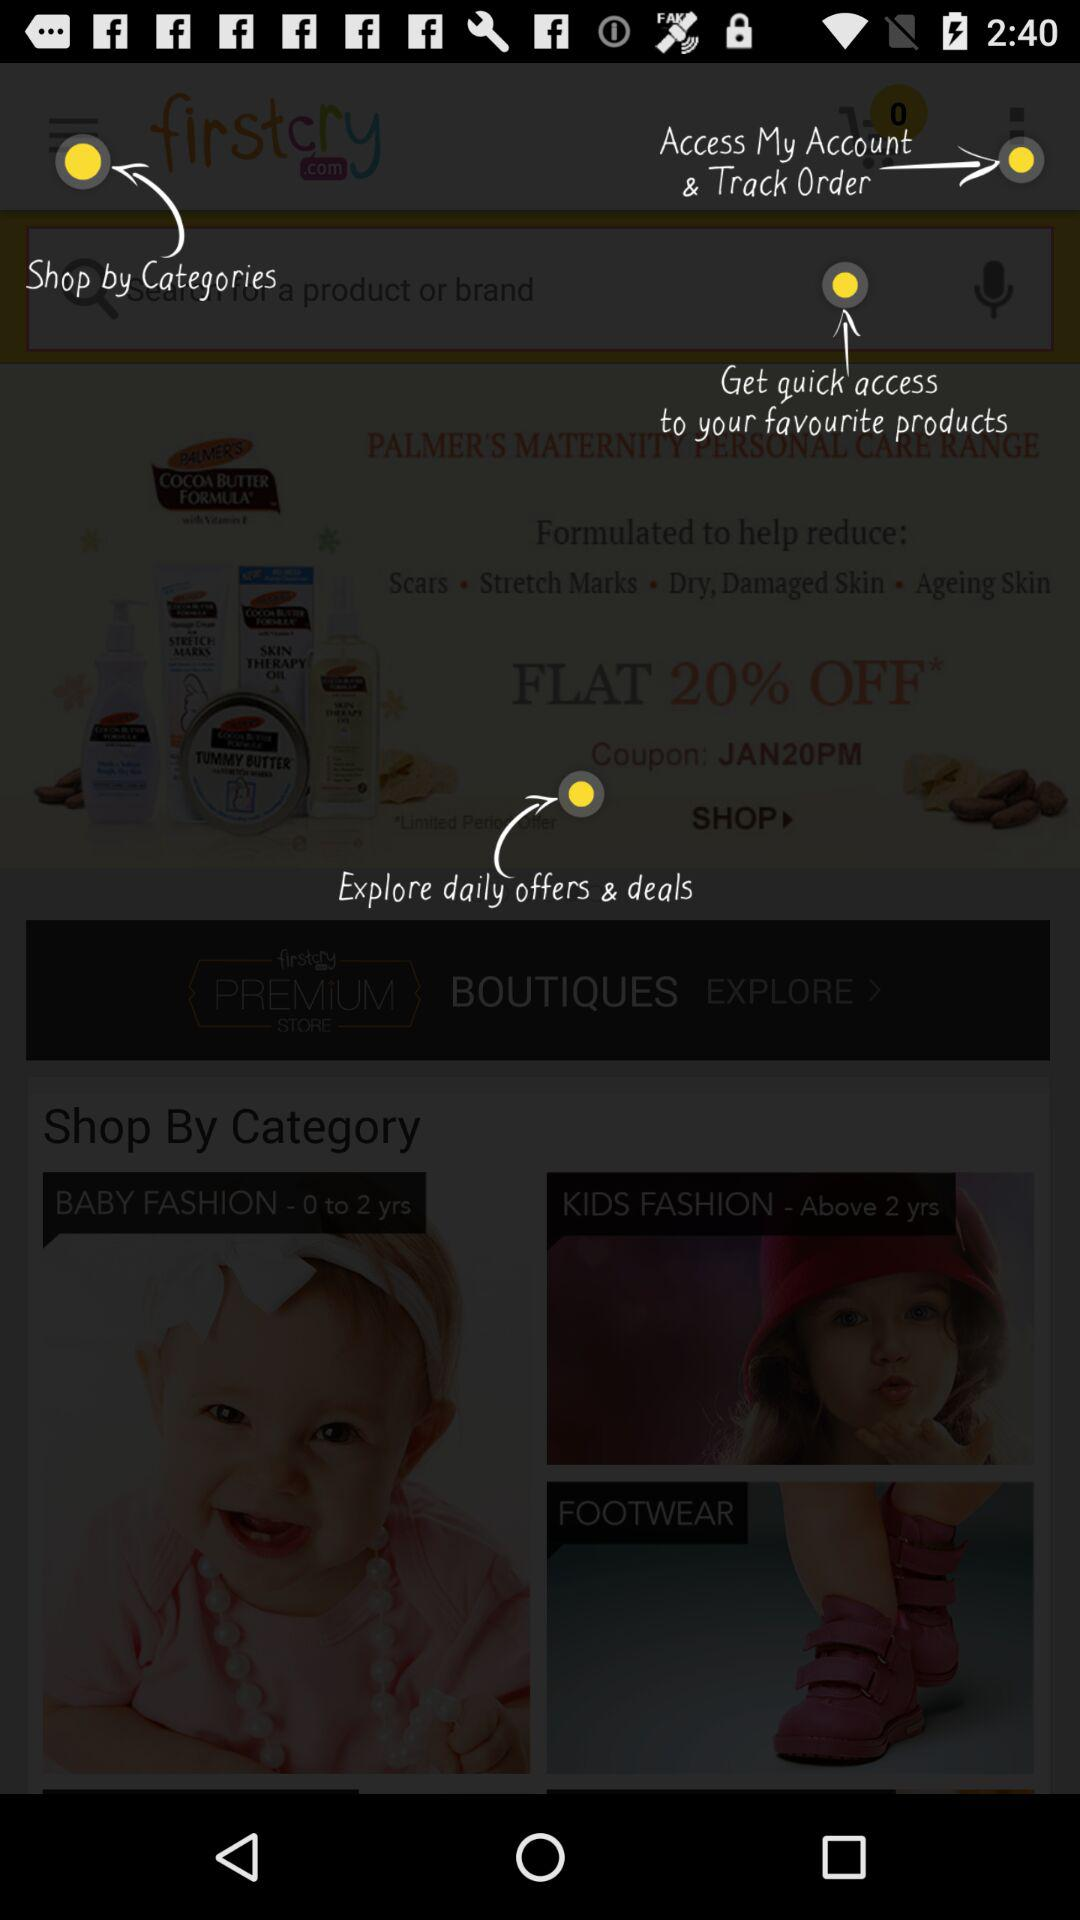What is the coupon code? The coupon code is "JAN20PM". 